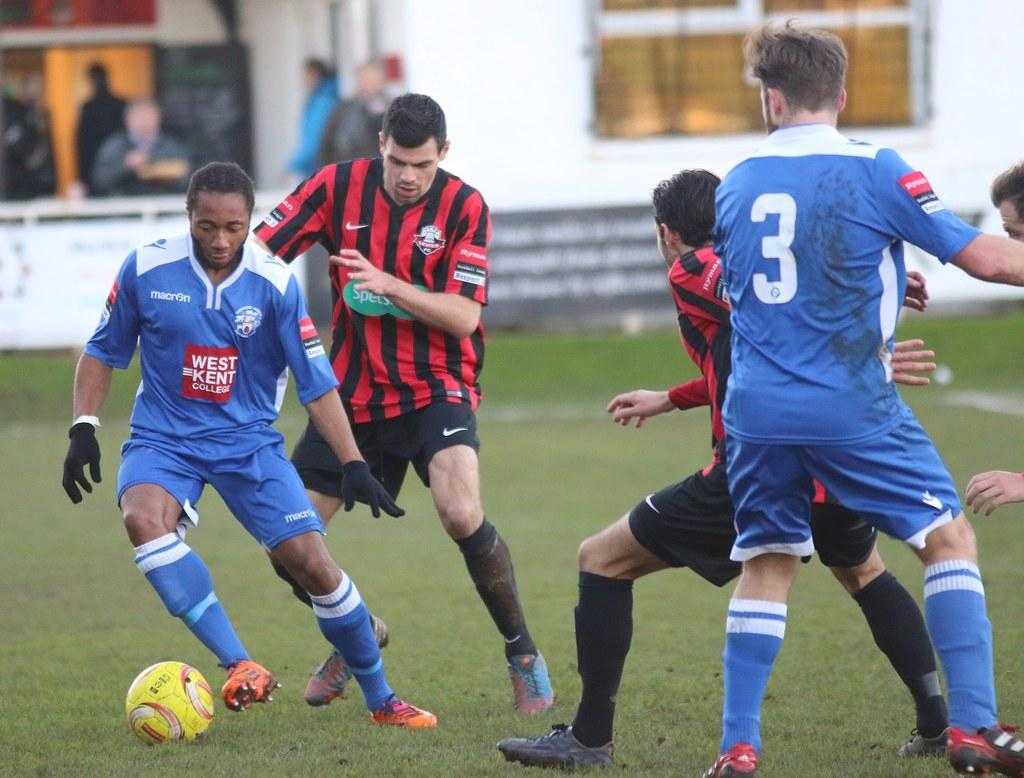What activity are the people in the image engaged in? The people in the image are playing football. What can be seen in the background of the image? There is a board and a wall in the background of the image. Are there any other people visible in the image? Yes, there are people visible in the background of the image. What type of donkey can be seen in the image? There is no donkey present in the image. What is the opinion of the people playing football about the game? The image does not provide any information about the opinions of the people playing football. 